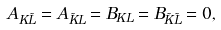<formula> <loc_0><loc_0><loc_500><loc_500>A _ { K \tilde { L } } = A _ { \tilde { K } L } = B _ { K L } = B _ { \tilde { K } \tilde { L } } = 0 ,</formula> 